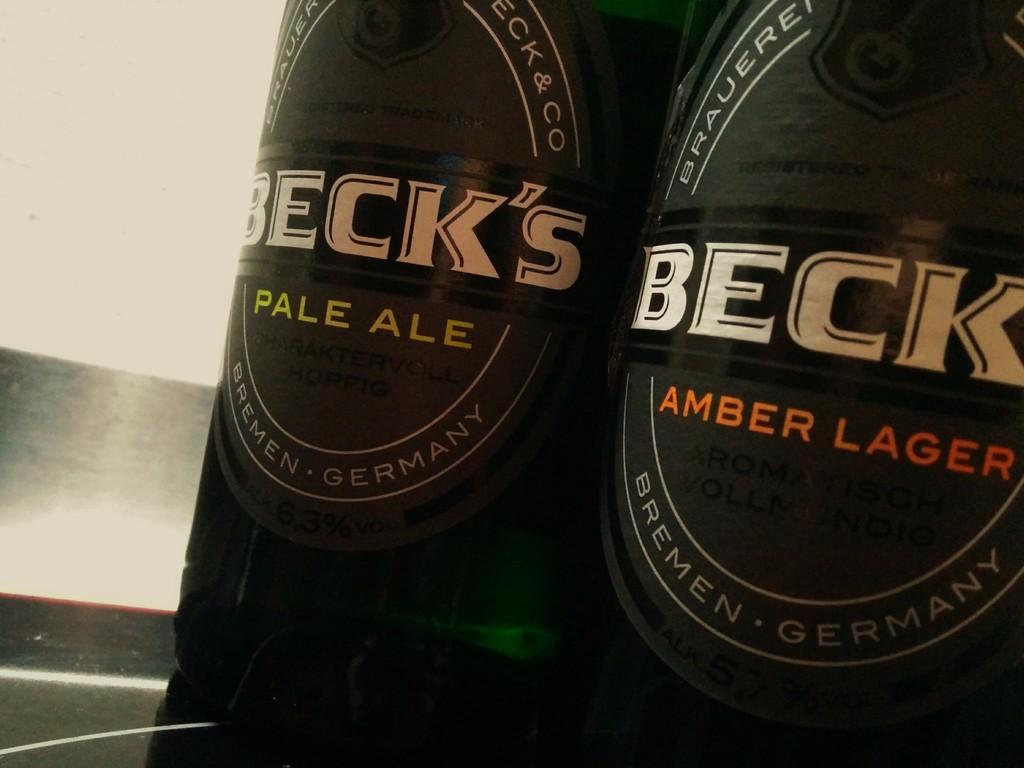What kind of lager was produced?
Offer a terse response. Amber. 